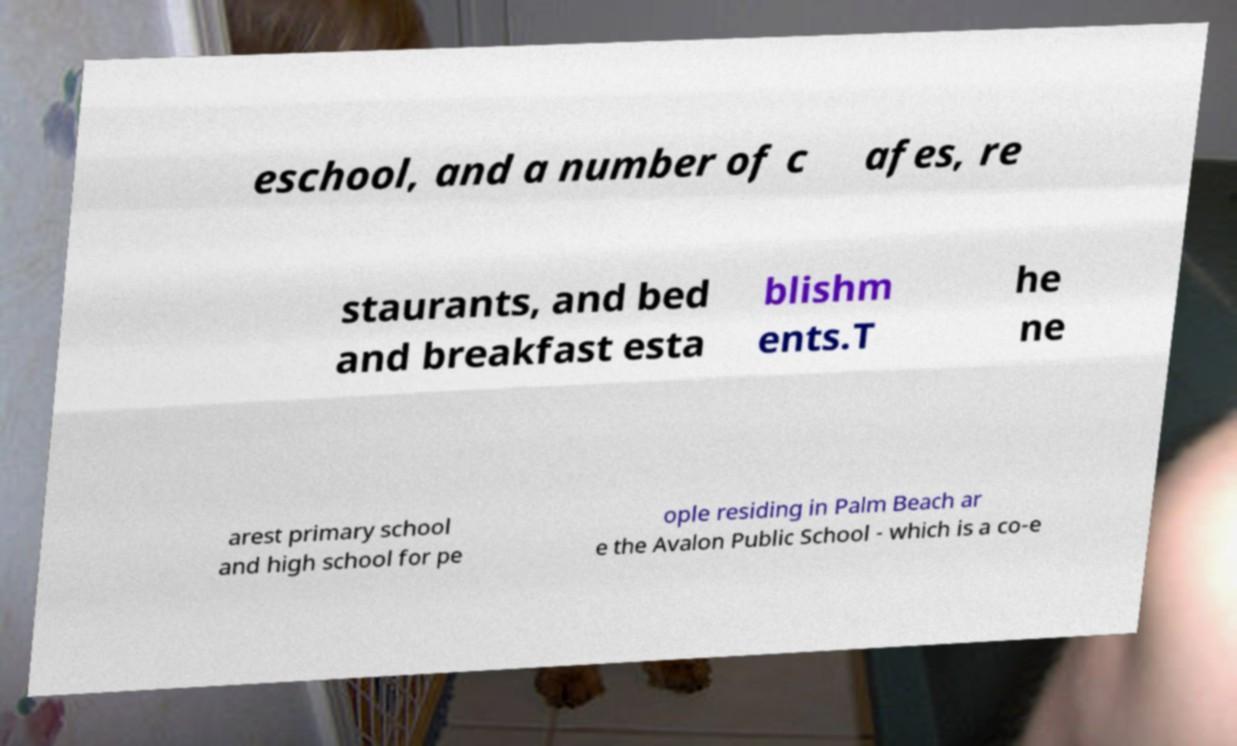Could you extract and type out the text from this image? eschool, and a number of c afes, re staurants, and bed and breakfast esta blishm ents.T he ne arest primary school and high school for pe ople residing in Palm Beach ar e the Avalon Public School - which is a co-e 